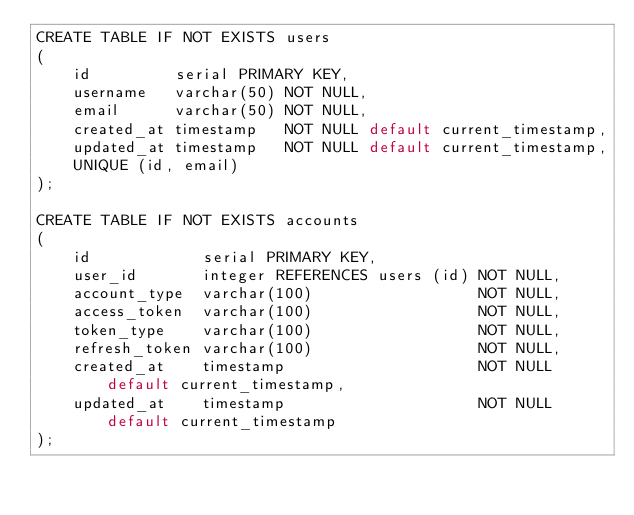<code> <loc_0><loc_0><loc_500><loc_500><_SQL_>CREATE TABLE IF NOT EXISTS users
(
    id         serial PRIMARY KEY,
    username   varchar(50) NOT NULL,
    email      varchar(50) NOT NULL,
    created_at timestamp   NOT NULL default current_timestamp,
    updated_at timestamp   NOT NULL default current_timestamp,
    UNIQUE (id, email)
);

CREATE TABLE IF NOT EXISTS accounts
(
    id            serial PRIMARY KEY,
    user_id       integer REFERENCES users (id) NOT NULL,
    account_type  varchar(100)                  NOT NULL,
    access_token  varchar(100)                  NOT NULL,
    token_type    varchar(100)                  NOT NULL,
    refresh_token varchar(100)                  NOT NULL,
    created_at    timestamp                     NOT NULL default current_timestamp,
    updated_at    timestamp                     NOT NULL default current_timestamp
);
</code> 